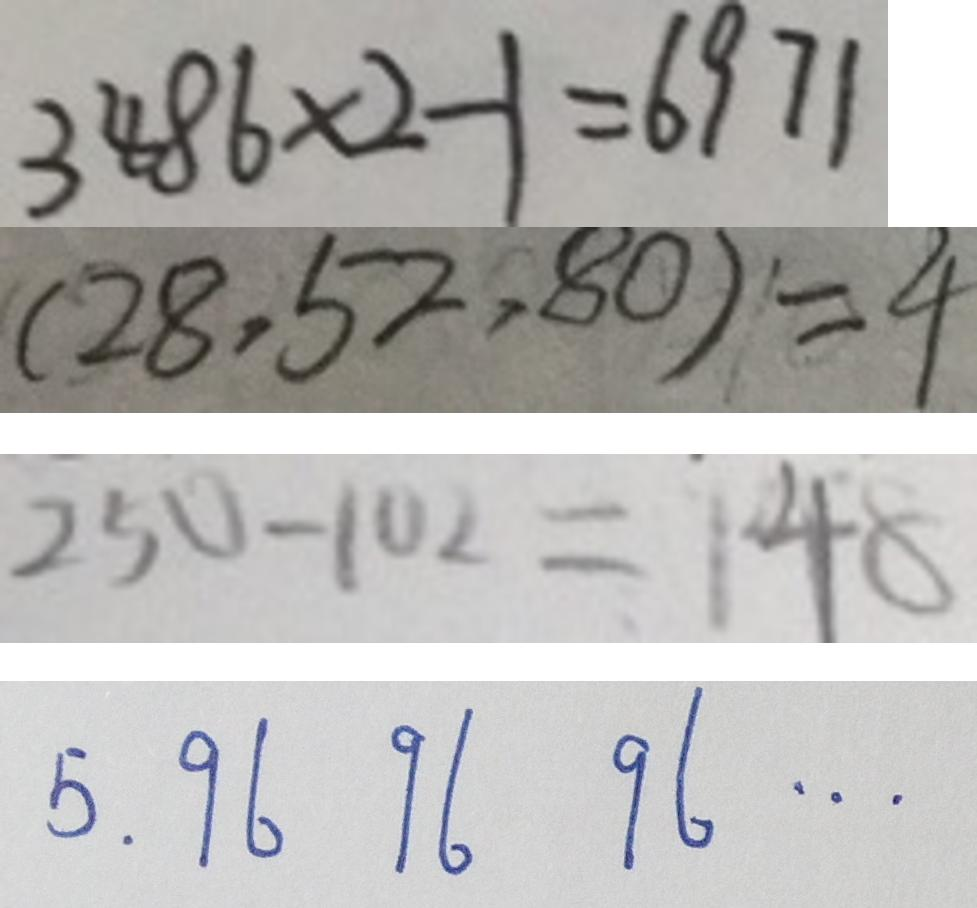Convert formula to latex. <formula><loc_0><loc_0><loc_500><loc_500>3 4 8 6 \times 2 - 1 = 6 9 7 1 
 ( 2 8 , 5 2 , 8 0 ) = 4 
 2 5 0 - 1 0 2 = 1 4 8 
 5 . 9 6 9 6 9 6 \cdots</formula> 